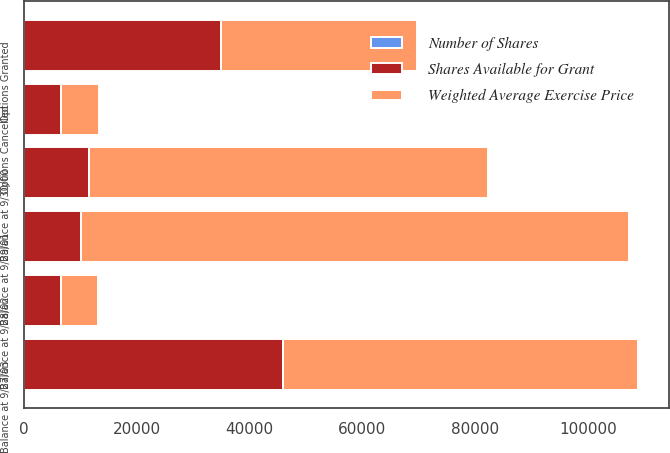Convert chart to OTSL. <chart><loc_0><loc_0><loc_500><loc_500><stacked_bar_chart><ecel><fcel>Balance at 9/30/00<fcel>Options Granted<fcel>Options Cancelled<fcel>Balance at 9/29/01<fcel>Balance at 9/28/02<fcel>Balance at 9/27/03<nl><fcel>Shares Available for Grant<fcel>11530<fcel>34857<fcel>6605<fcel>10075<fcel>6571<fcel>45830<nl><fcel>Weighted Average Exercise Price<fcel>70758<fcel>34857<fcel>6605<fcel>97179<fcel>6605<fcel>63012<nl><fcel>Number of Shares<fcel>34.01<fcel>18.58<fcel>29.32<fcel>29.24<fcel>28.17<fcel>19.08<nl></chart> 